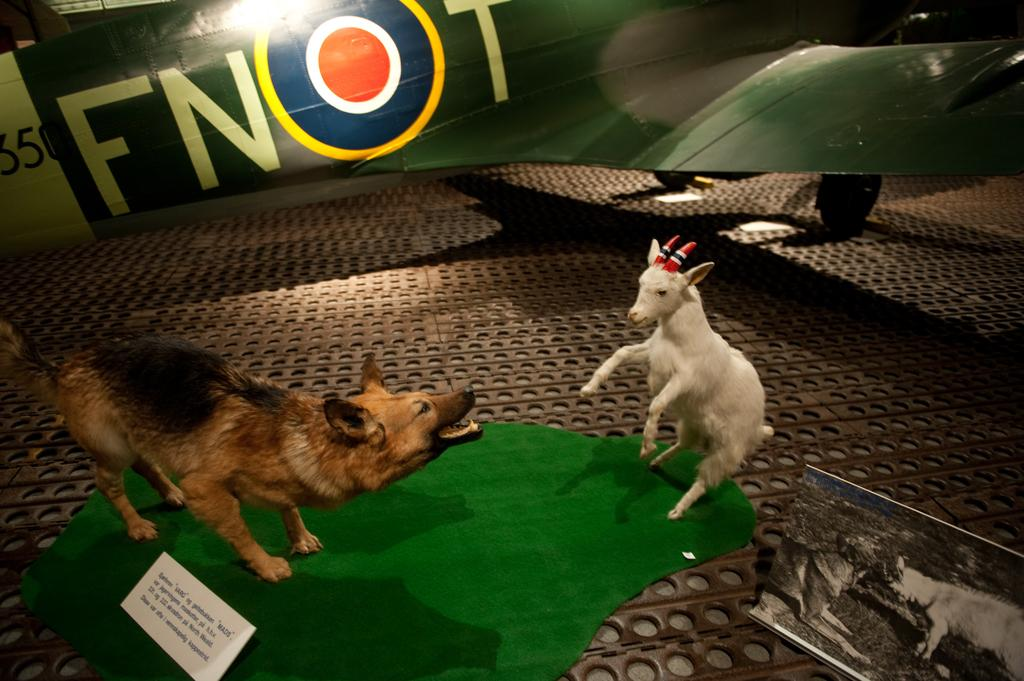What types of animals can be seen in the image? There are two animals in the image. What is on the floor in the image? There is a green cloth on the floor in the image. What else is visible in the image besides the animals and the green cloth? There is an aircraft visible in the image. What type of crook can be seen holding the aircraft in the image? There is no crook present in the image, nor is there any indication that the aircraft is being held by anyone or anything. 